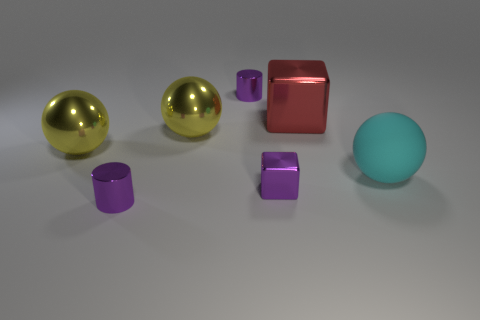Add 2 big metallic balls. How many objects exist? 9 Subtract all blocks. How many objects are left? 5 Add 3 purple metal cubes. How many purple metal cubes exist? 4 Subtract 0 gray cubes. How many objects are left? 7 Subtract all big red things. Subtract all big cubes. How many objects are left? 5 Add 5 large red things. How many large red things are left? 6 